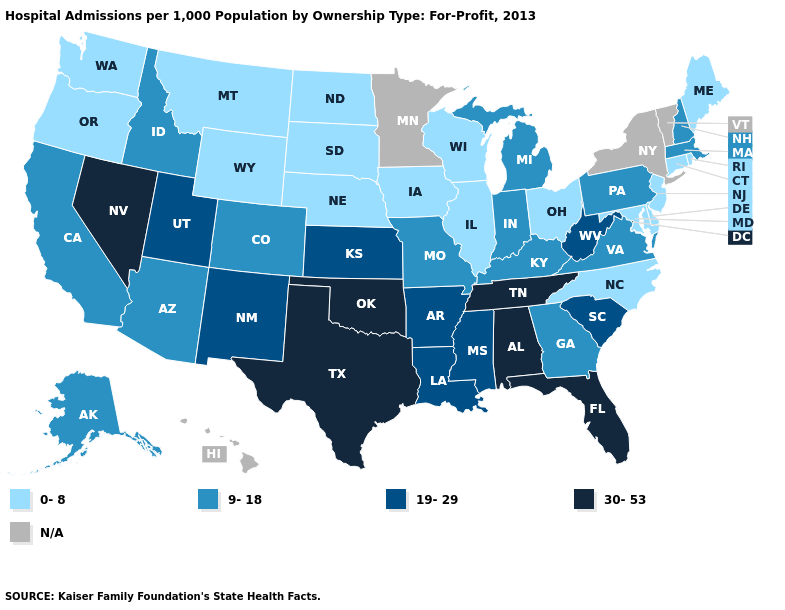Which states hav the highest value in the South?
Short answer required. Alabama, Florida, Oklahoma, Tennessee, Texas. What is the value of West Virginia?
Give a very brief answer. 19-29. Does Connecticut have the highest value in the Northeast?
Short answer required. No. What is the highest value in states that border Washington?
Write a very short answer. 9-18. Name the states that have a value in the range 19-29?
Quick response, please. Arkansas, Kansas, Louisiana, Mississippi, New Mexico, South Carolina, Utah, West Virginia. Which states have the highest value in the USA?
Answer briefly. Alabama, Florida, Nevada, Oklahoma, Tennessee, Texas. Among the states that border Illinois , which have the lowest value?
Keep it brief. Iowa, Wisconsin. What is the value of Oklahoma?
Give a very brief answer. 30-53. How many symbols are there in the legend?
Write a very short answer. 5. Name the states that have a value in the range N/A?
Answer briefly. Hawaii, Minnesota, New York, Vermont. Name the states that have a value in the range 9-18?
Write a very short answer. Alaska, Arizona, California, Colorado, Georgia, Idaho, Indiana, Kentucky, Massachusetts, Michigan, Missouri, New Hampshire, Pennsylvania, Virginia. Does the map have missing data?
Concise answer only. Yes. Among the states that border Florida , which have the highest value?
Answer briefly. Alabama. What is the value of Mississippi?
Be succinct. 19-29. 